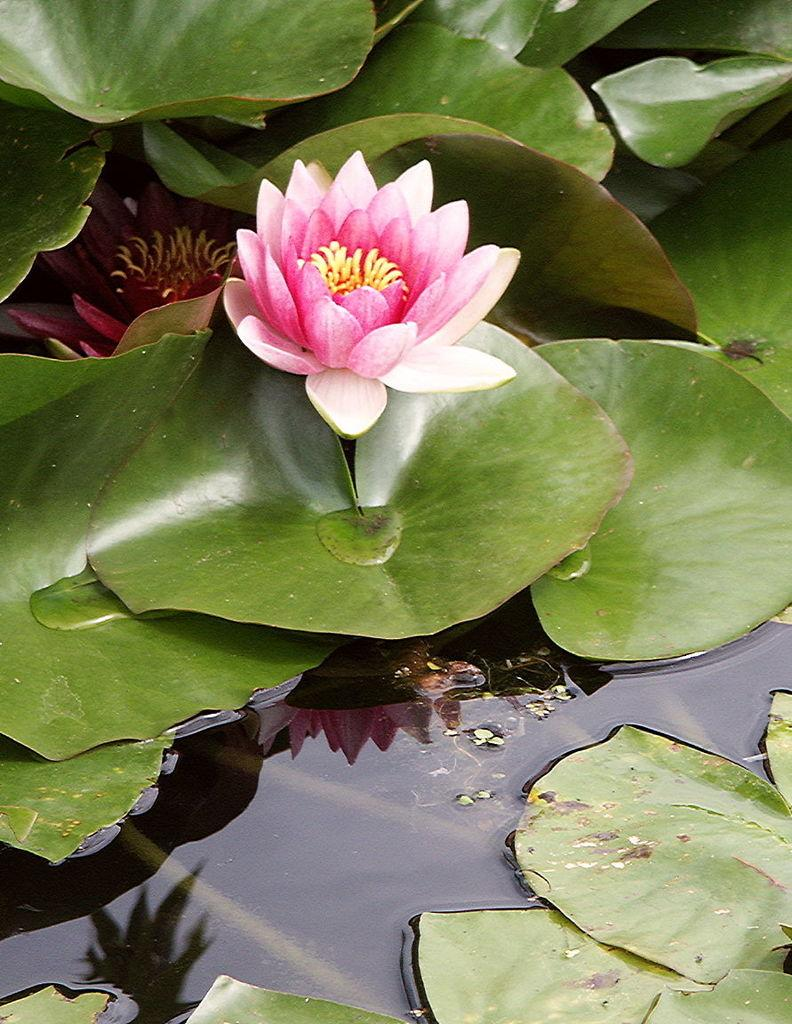What type of plants can be seen in the image? There are flowers and leaves in the image. What is the primary element in which the flowers and leaves are situated? The flowers and leaves are floating on the water. What type of crown can be seen on the zinc in the image? There is no crown or zinc present in the image; it features flowers and leaves floating on water. 